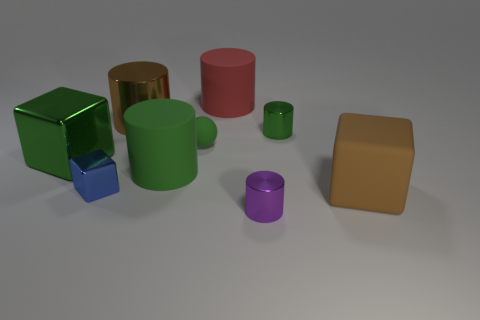Subtract all small shiny blocks. How many blocks are left? 2 Subtract 4 cylinders. How many cylinders are left? 1 Subtract all green blocks. How many blocks are left? 2 Subtract all cylinders. How many objects are left? 4 Subtract all green cylinders. How many green blocks are left? 1 Subtract all small green shiny cylinders. Subtract all purple cylinders. How many objects are left? 7 Add 8 small green spheres. How many small green spheres are left? 9 Add 3 big cubes. How many big cubes exist? 5 Add 1 purple objects. How many objects exist? 10 Subtract 0 yellow spheres. How many objects are left? 9 